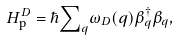Convert formula to latex. <formula><loc_0><loc_0><loc_500><loc_500>H ^ { D } _ { \text {p} } = \hbar { \sum } _ { q } \omega _ { D } ( q ) \beta _ { q } ^ { \dagger } \beta _ { q } ,</formula> 